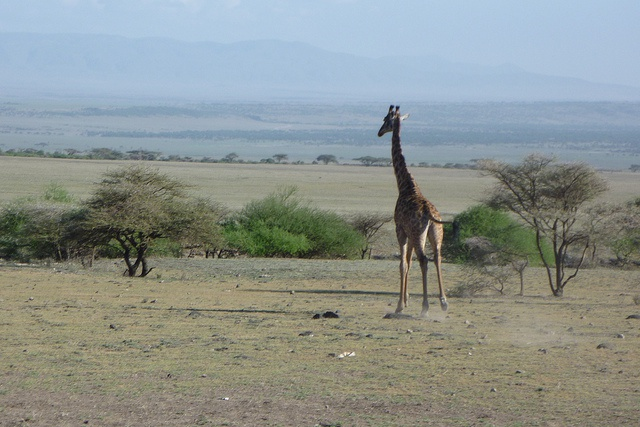Describe the objects in this image and their specific colors. I can see a giraffe in lightblue, black, gray, and darkgray tones in this image. 